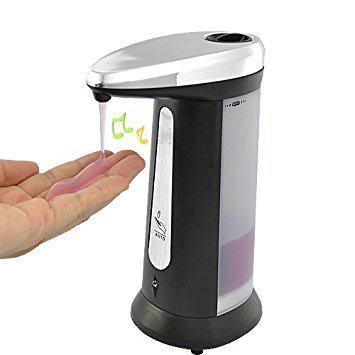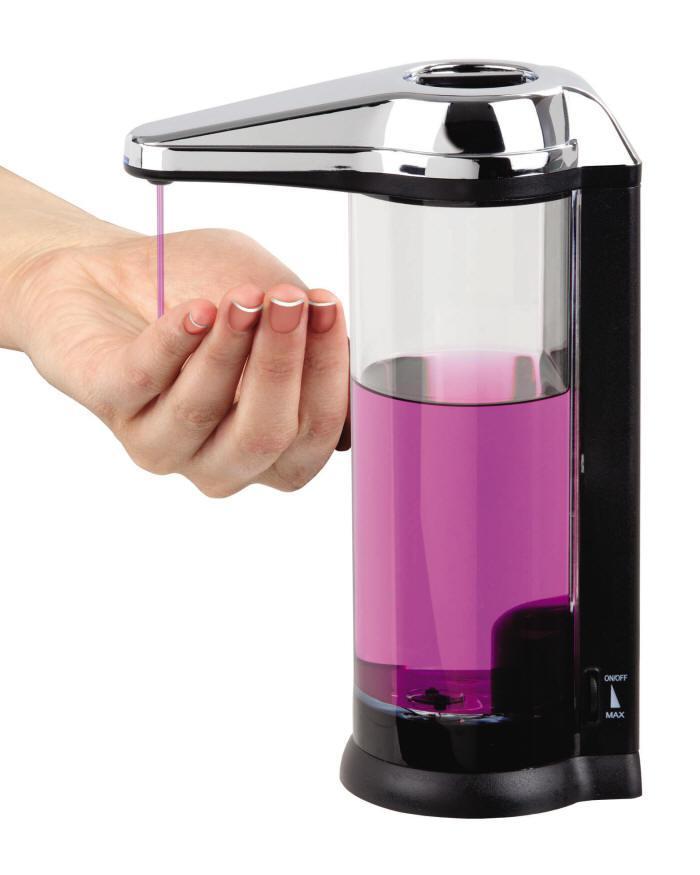The first image is the image on the left, the second image is the image on the right. For the images shown, is this caption "There is a hand in the image on the right" true? Answer yes or no. Yes. The first image is the image on the left, the second image is the image on the right. Evaluate the accuracy of this statement regarding the images: "One image has no hands.". Is it true? Answer yes or no. No. 